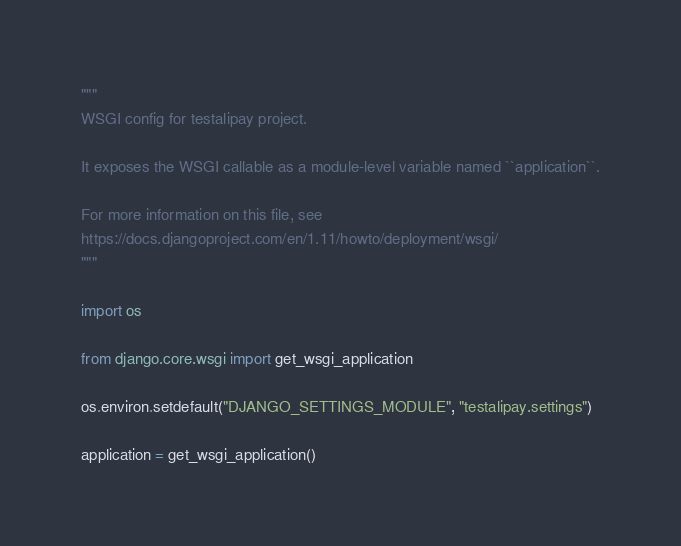<code> <loc_0><loc_0><loc_500><loc_500><_Python_>"""
WSGI config for testalipay project.

It exposes the WSGI callable as a module-level variable named ``application``.

For more information on this file, see
https://docs.djangoproject.com/en/1.11/howto/deployment/wsgi/
"""

import os

from django.core.wsgi import get_wsgi_application

os.environ.setdefault("DJANGO_SETTINGS_MODULE", "testalipay.settings")

application = get_wsgi_application()
</code> 